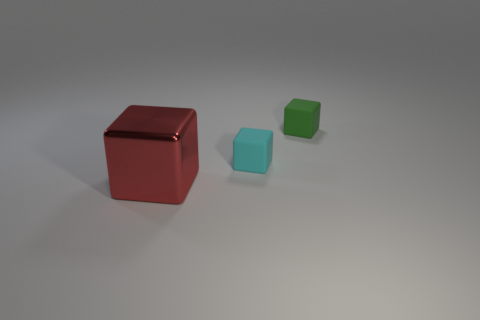Add 2 tiny green cubes. How many objects exist? 5 Subtract all tiny cyan matte blocks. How many blocks are left? 2 Subtract all green blocks. How many blocks are left? 2 Add 3 cyan blocks. How many cyan blocks are left? 4 Add 3 red blocks. How many red blocks exist? 4 Subtract 1 red cubes. How many objects are left? 2 Subtract all gray blocks. Subtract all yellow cylinders. How many blocks are left? 3 Subtract all large red shiny blocks. Subtract all small green blocks. How many objects are left? 1 